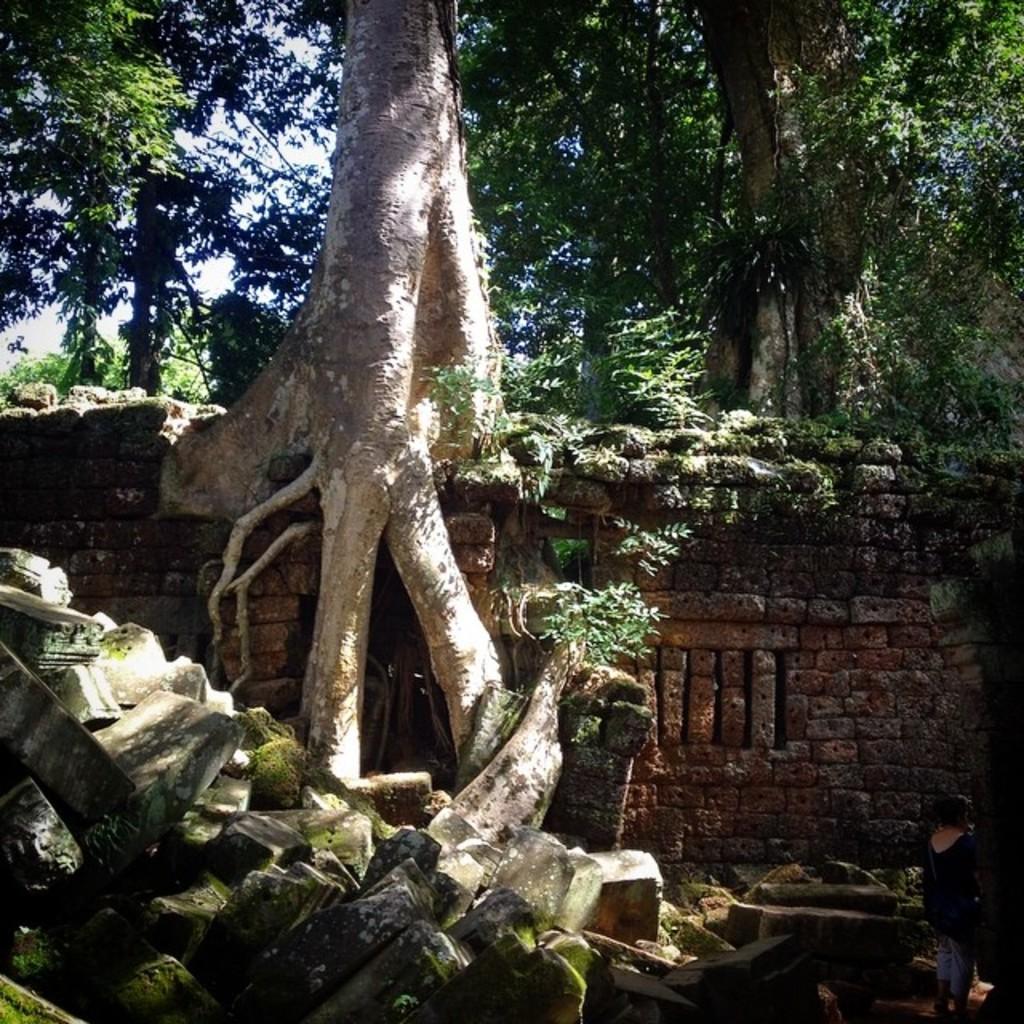How would you summarize this image in a sentence or two? In this image I can see a brick wall and a tree above wall whose roots are coming down through the wall. I can see some stones in the left bottom corner and a person standing in the right bottom corner. I can see other trees above the wall at the top of the image. 